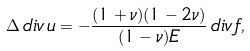Convert formula to latex. <formula><loc_0><loc_0><loc_500><loc_500>\Delta \, d i v \, { u } = - \frac { ( 1 + \nu ) ( 1 - 2 \nu ) } { ( 1 - \nu ) E } \, d i v \, { f } ,</formula> 